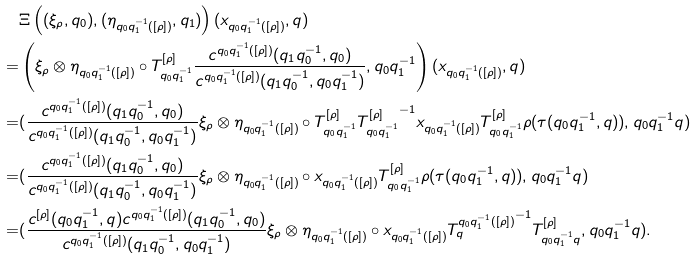Convert formula to latex. <formula><loc_0><loc_0><loc_500><loc_500>& \Xi \left ( ( \xi _ { \rho } , q _ { 0 } ) , ( \eta _ { q _ { 0 } q _ { 1 } ^ { - 1 } ( [ \rho ] ) } , q _ { 1 } ) \right ) ( x _ { q _ { 0 } q _ { 1 } ^ { - 1 } ( [ \rho ] ) } , q ) \\ = & \left ( \xi _ { \rho } \otimes \eta _ { q _ { 0 } q _ { 1 } ^ { - 1 } ( [ \rho ] ) } \circ T ^ { [ \rho ] } _ { q _ { 0 } q _ { 1 } ^ { - 1 } } \frac { c ^ { q _ { 0 } q _ { 1 } ^ { - 1 } ( [ \rho ] ) } ( q _ { 1 } q _ { 0 } ^ { - 1 } , q _ { 0 } ) } { c ^ { q _ { 0 } q _ { 1 } ^ { - 1 } ( [ \rho ] ) } ( q _ { 1 } q _ { 0 } ^ { - 1 } , q _ { 0 } q _ { 1 } ^ { - 1 } ) } , q _ { 0 } q _ { 1 } ^ { - 1 } \right ) ( x _ { q _ { 0 } q _ { 1 } ^ { - 1 } ( [ \rho ] ) } , q ) \\ = & ( \frac { c ^ { q _ { 0 } q _ { 1 } ^ { - 1 } ( [ \rho ] ) } ( q _ { 1 } q _ { 0 } ^ { - 1 } , q _ { 0 } ) } { c ^ { q _ { 0 } q _ { 1 } ^ { - 1 } ( [ \rho ] ) } ( q _ { 1 } q _ { 0 } ^ { - 1 } , q _ { 0 } q _ { 1 } ^ { - 1 } ) } \xi _ { \rho } \otimes \eta _ { q _ { 0 } q _ { 1 } ^ { - 1 } ( [ \rho ] ) } \circ T ^ { [ \rho ] } _ { q _ { 0 } q _ { 1 } ^ { - 1 } } { T ^ { [ \rho ] } _ { q _ { 0 } q _ { 1 } ^ { - 1 } } } ^ { - 1 } x _ { q _ { 0 } q _ { 1 } ^ { - 1 } ( [ \rho ] ) } T ^ { [ \rho ] } _ { q _ { 0 } q _ { 1 } ^ { - 1 } } \rho ( \tau ( q _ { 0 } q _ { 1 } ^ { - 1 } , q ) ) , q _ { 0 } q _ { 1 } ^ { - 1 } q ) \\ = & ( \frac { c ^ { q _ { 0 } q _ { 1 } ^ { - 1 } ( [ \rho ] ) } ( q _ { 1 } q _ { 0 } ^ { - 1 } , q _ { 0 } ) } { c ^ { q _ { 0 } q _ { 1 } ^ { - 1 } ( [ \rho ] ) } ( q _ { 1 } q _ { 0 } ^ { - 1 } , q _ { 0 } q _ { 1 } ^ { - 1 } ) } \xi _ { \rho } \otimes \eta _ { q _ { 0 } q _ { 1 } ^ { - 1 } ( [ \rho ] ) } \circ x _ { q _ { 0 } q _ { 1 } ^ { - 1 } ( [ \rho ] ) } T ^ { [ \rho ] } _ { q _ { 0 } q _ { 1 } ^ { - 1 } } \rho ( \tau ( q _ { 0 } q _ { 1 } ^ { - 1 } , q ) ) , q _ { 0 } q _ { 1 } ^ { - 1 } q ) \\ = & ( \frac { c ^ { [ \rho ] } ( q _ { 0 } q _ { 1 } ^ { - 1 } , q ) c ^ { q _ { 0 } q _ { 1 } ^ { - 1 } ( [ \rho ] ) } ( q _ { 1 } q _ { 0 } ^ { - 1 } , q _ { 0 } ) } { c ^ { q _ { 0 } q _ { 1 } ^ { - 1 } ( [ \rho ] ) } ( q _ { 1 } q _ { 0 } ^ { - 1 } , q _ { 0 } q _ { 1 } ^ { - 1 } ) } \xi _ { \rho } \otimes \eta _ { q _ { 0 } q _ { 1 } ^ { - 1 } ( [ \rho ] ) } \circ x _ { q _ { 0 } q _ { 1 } ^ { - 1 } ( [ \rho ] ) } { T ^ { q _ { 0 } q _ { 1 } ^ { - 1 } ( [ \rho ] ) } _ { q } } ^ { - 1 } T ^ { [ \rho ] } _ { q _ { 0 } q _ { 1 } ^ { - 1 } q } , q _ { 0 } q _ { 1 } ^ { - 1 } q ) .</formula> 